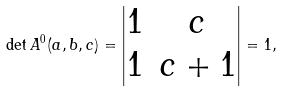<formula> <loc_0><loc_0><loc_500><loc_500>\det A ^ { 0 } ( a , b , c ) = \begin{vmatrix} 1 & c \\ 1 & c + 1 \end{vmatrix} = 1 ,</formula> 